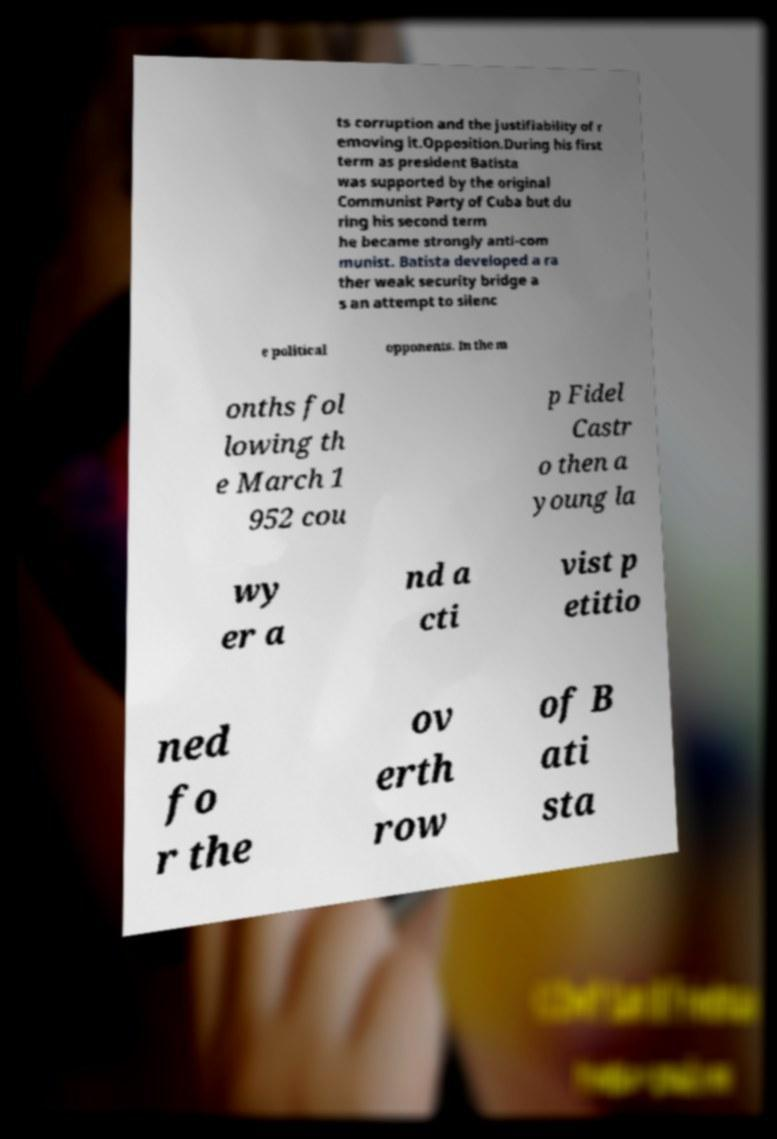Please identify and transcribe the text found in this image. ts corruption and the justifiability of r emoving it.Opposition.During his first term as president Batista was supported by the original Communist Party of Cuba but du ring his second term he became strongly anti-com munist. Batista developed a ra ther weak security bridge a s an attempt to silenc e political opponents. In the m onths fol lowing th e March 1 952 cou p Fidel Castr o then a young la wy er a nd a cti vist p etitio ned fo r the ov erth row of B ati sta 